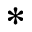<formula> <loc_0><loc_0><loc_500><loc_500>^ { * }</formula> 